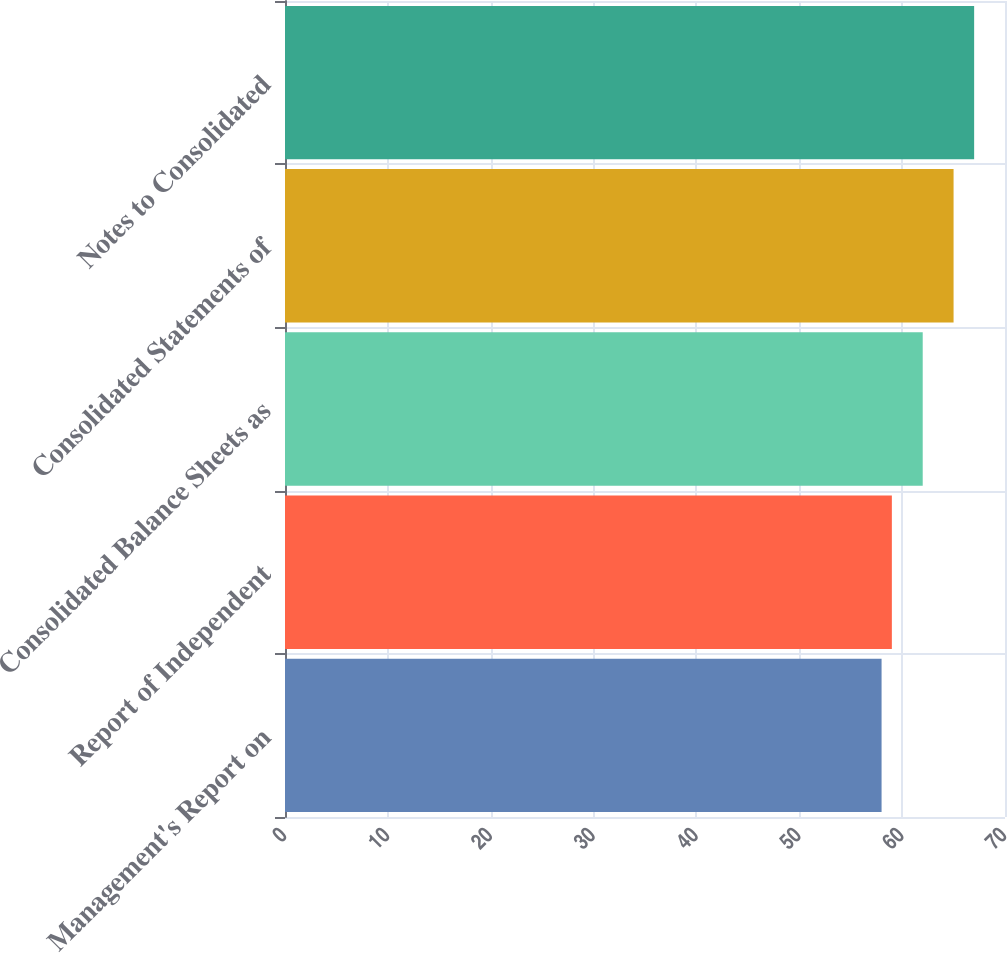<chart> <loc_0><loc_0><loc_500><loc_500><bar_chart><fcel>Management's Report on<fcel>Report of Independent<fcel>Consolidated Balance Sheets as<fcel>Consolidated Statements of<fcel>Notes to Consolidated<nl><fcel>58<fcel>59<fcel>62<fcel>65<fcel>67<nl></chart> 